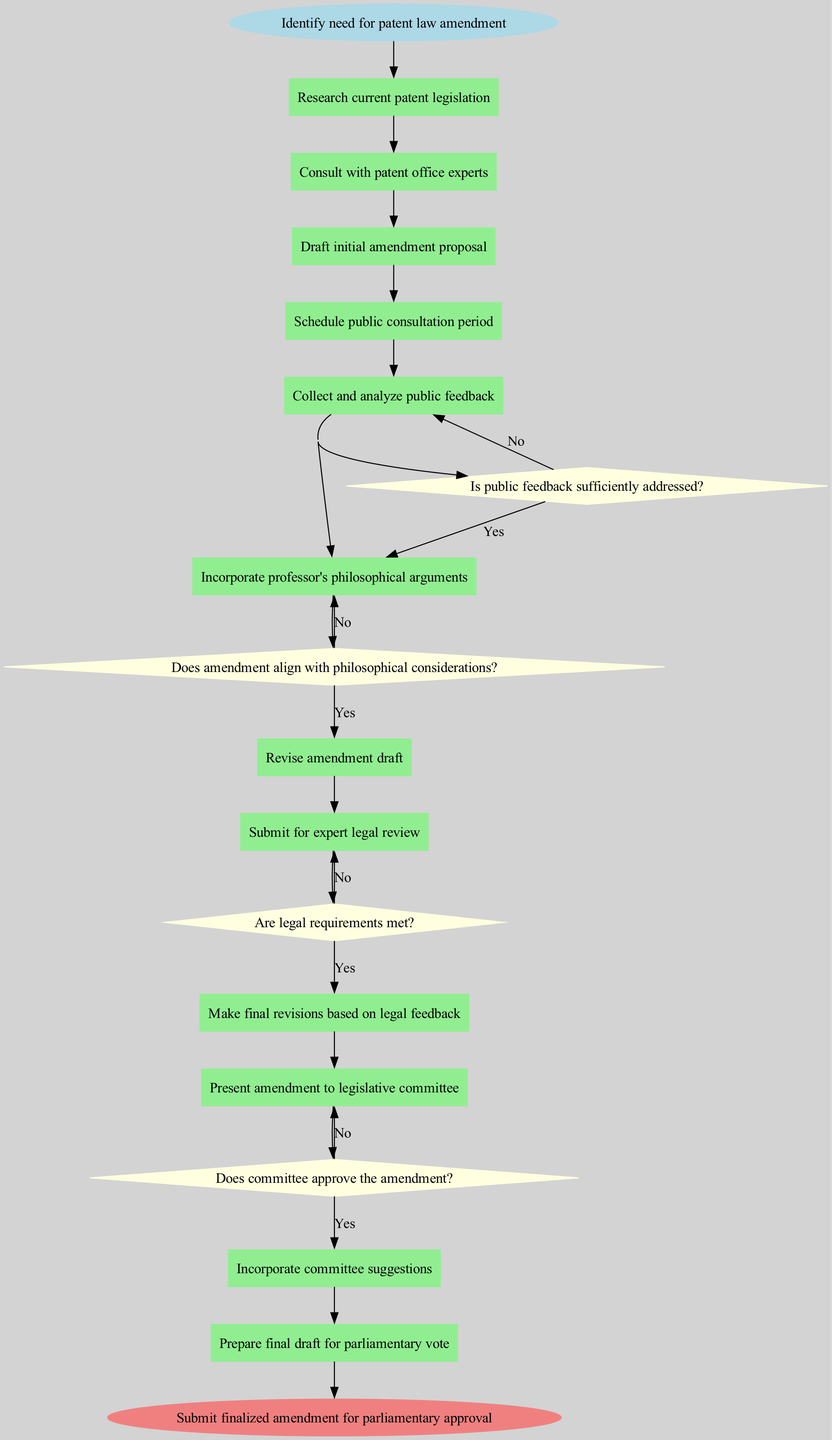What is the starting activity in the diagram? The starting activity is labeled as "Identify need for patent law amendment" which is the first activity node in the sequence.
Answer: Identify need for patent law amendment How many activities are listed in the diagram? Counting all the listed activities from the starting point to the end shows there are 12 activities in total, including the start and end nodes.
Answer: 12 What decision follows the "Schedule public consultation period" activity? The decision that follows is "Is public feedback sufficiently addressed?" which is directly connected after the activity.
Answer: Is public feedback sufficiently addressed? What activity occurs just before the final submission for parliamentary approval? The activity that occurs just before the final submission is "Prepare final draft for parliamentary vote," as it is the last activity leading to the end node.
Answer: Prepare final draft for parliamentary vote What happens if the "Does committee approve the amendment?" decision is answered with "No"? If the answer is "No," the process loops back to "Incorporate committee suggestions," indicating further revision is required before resubmission to the committee.
Answer: Incorporate committee suggestions What is the role of the decision labeled "Does amendment align with philosophical considerations?" This decision serves to ensure that the drafted amendment incorporates the philosophical arguments presented by the professor before moving to the next activity.
Answer: Ensure incorporation of philosophical arguments How many decision points are present in the diagram? There are four decision points in the diagram, each prompting a crucial evaluation step within the legislative drafting workflow.
Answer: 4 Which activity follows the incorporation of public feedback? The next activity is "Incorporate professor's philosophical arguments," indicating that public input is integrated and considered in drafting.
Answer: Incorporate professor's philosophical arguments What is the end goal of the workflow described in the diagram? The end goal is defined as "Submit finalized amendment for parliamentary approval," completing the legislative process outlined.
Answer: Submit finalized amendment for parliamentary approval 